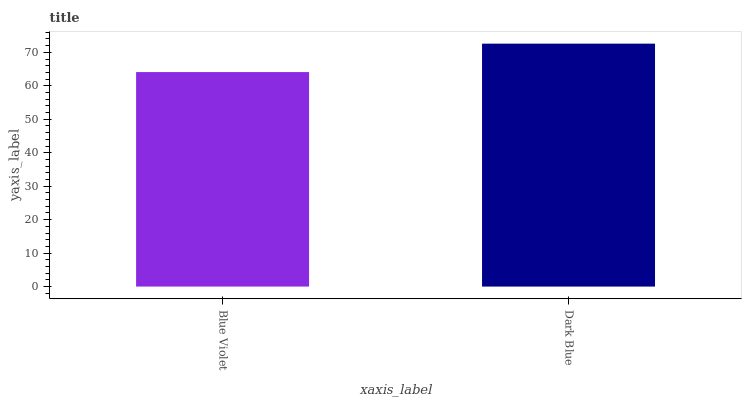Is Blue Violet the minimum?
Answer yes or no. Yes. Is Dark Blue the maximum?
Answer yes or no. Yes. Is Dark Blue the minimum?
Answer yes or no. No. Is Dark Blue greater than Blue Violet?
Answer yes or no. Yes. Is Blue Violet less than Dark Blue?
Answer yes or no. Yes. Is Blue Violet greater than Dark Blue?
Answer yes or no. No. Is Dark Blue less than Blue Violet?
Answer yes or no. No. Is Dark Blue the high median?
Answer yes or no. Yes. Is Blue Violet the low median?
Answer yes or no. Yes. Is Blue Violet the high median?
Answer yes or no. No. Is Dark Blue the low median?
Answer yes or no. No. 